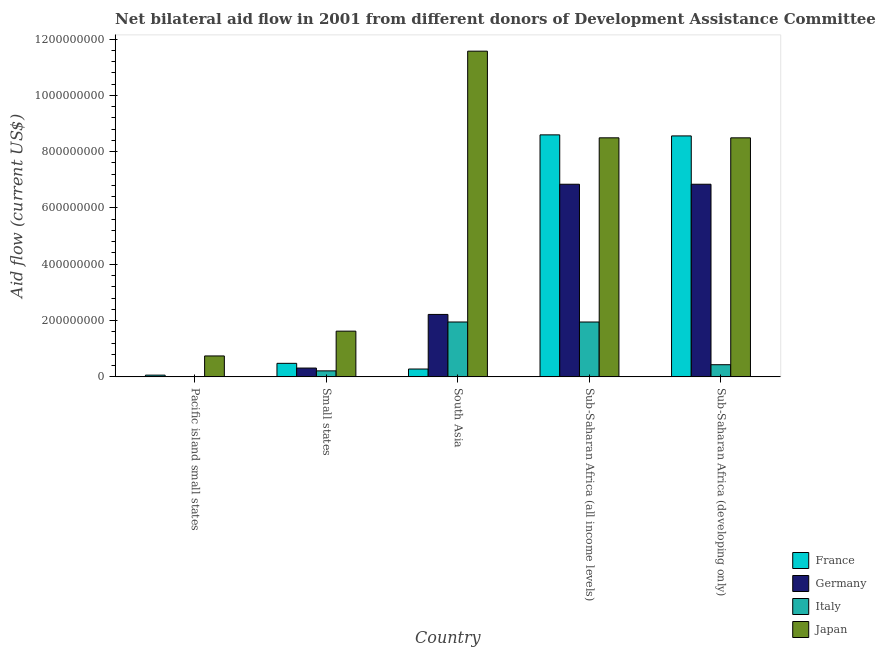How many different coloured bars are there?
Provide a succinct answer. 4. Are the number of bars per tick equal to the number of legend labels?
Ensure brevity in your answer.  No. How many bars are there on the 1st tick from the left?
Provide a short and direct response. 2. How many bars are there on the 1st tick from the right?
Ensure brevity in your answer.  4. What is the amount of aid given by japan in Sub-Saharan Africa (developing only)?
Provide a short and direct response. 8.49e+08. Across all countries, what is the maximum amount of aid given by italy?
Offer a terse response. 1.95e+08. In which country was the amount of aid given by germany maximum?
Offer a very short reply. Sub-Saharan Africa (all income levels). What is the total amount of aid given by japan in the graph?
Ensure brevity in your answer.  3.09e+09. What is the difference between the amount of aid given by japan in South Asia and that in Sub-Saharan Africa (all income levels)?
Offer a very short reply. 3.08e+08. What is the difference between the amount of aid given by france in Pacific island small states and the amount of aid given by italy in Sub-Saharan Africa (developing only)?
Make the answer very short. -3.71e+07. What is the average amount of aid given by japan per country?
Your response must be concise. 6.18e+08. What is the difference between the amount of aid given by germany and amount of aid given by italy in Small states?
Keep it short and to the point. 9.96e+06. In how many countries, is the amount of aid given by france greater than 1000000000 US$?
Your response must be concise. 0. What is the ratio of the amount of aid given by france in Small states to that in Sub-Saharan Africa (developing only)?
Your response must be concise. 0.06. Is the amount of aid given by italy in Small states less than that in Sub-Saharan Africa (all income levels)?
Your answer should be very brief. Yes. Is the difference between the amount of aid given by germany in South Asia and Sub-Saharan Africa (developing only) greater than the difference between the amount of aid given by france in South Asia and Sub-Saharan Africa (developing only)?
Offer a very short reply. Yes. What is the difference between the highest and the second highest amount of aid given by france?
Ensure brevity in your answer.  3.73e+06. What is the difference between the highest and the lowest amount of aid given by france?
Give a very brief answer. 8.53e+08. Is it the case that in every country, the sum of the amount of aid given by france and amount of aid given by germany is greater than the amount of aid given by italy?
Ensure brevity in your answer.  Yes. How many bars are there?
Offer a terse response. 18. How many countries are there in the graph?
Give a very brief answer. 5. Does the graph contain grids?
Give a very brief answer. No. Where does the legend appear in the graph?
Ensure brevity in your answer.  Bottom right. What is the title of the graph?
Ensure brevity in your answer.  Net bilateral aid flow in 2001 from different donors of Development Assistance Committee. What is the label or title of the Y-axis?
Offer a very short reply. Aid flow (current US$). What is the Aid flow (current US$) of France in Pacific island small states?
Make the answer very short. 6.15e+06. What is the Aid flow (current US$) in Germany in Pacific island small states?
Offer a terse response. 0. What is the Aid flow (current US$) in Italy in Pacific island small states?
Your response must be concise. 0. What is the Aid flow (current US$) in Japan in Pacific island small states?
Provide a short and direct response. 7.44e+07. What is the Aid flow (current US$) in France in Small states?
Your answer should be compact. 4.81e+07. What is the Aid flow (current US$) in Germany in Small states?
Your answer should be compact. 3.13e+07. What is the Aid flow (current US$) in Italy in Small states?
Your response must be concise. 2.14e+07. What is the Aid flow (current US$) in Japan in Small states?
Ensure brevity in your answer.  1.62e+08. What is the Aid flow (current US$) in France in South Asia?
Ensure brevity in your answer.  2.79e+07. What is the Aid flow (current US$) in Germany in South Asia?
Make the answer very short. 2.22e+08. What is the Aid flow (current US$) in Italy in South Asia?
Give a very brief answer. 1.95e+08. What is the Aid flow (current US$) in Japan in South Asia?
Keep it short and to the point. 1.16e+09. What is the Aid flow (current US$) of France in Sub-Saharan Africa (all income levels)?
Ensure brevity in your answer.  8.60e+08. What is the Aid flow (current US$) of Germany in Sub-Saharan Africa (all income levels)?
Provide a short and direct response. 6.84e+08. What is the Aid flow (current US$) of Italy in Sub-Saharan Africa (all income levels)?
Keep it short and to the point. 1.95e+08. What is the Aid flow (current US$) in Japan in Sub-Saharan Africa (all income levels)?
Offer a very short reply. 8.49e+08. What is the Aid flow (current US$) in France in Sub-Saharan Africa (developing only)?
Ensure brevity in your answer.  8.56e+08. What is the Aid flow (current US$) in Germany in Sub-Saharan Africa (developing only)?
Provide a succinct answer. 6.84e+08. What is the Aid flow (current US$) in Italy in Sub-Saharan Africa (developing only)?
Your response must be concise. 4.32e+07. What is the Aid flow (current US$) of Japan in Sub-Saharan Africa (developing only)?
Provide a succinct answer. 8.49e+08. Across all countries, what is the maximum Aid flow (current US$) of France?
Ensure brevity in your answer.  8.60e+08. Across all countries, what is the maximum Aid flow (current US$) of Germany?
Give a very brief answer. 6.84e+08. Across all countries, what is the maximum Aid flow (current US$) of Italy?
Ensure brevity in your answer.  1.95e+08. Across all countries, what is the maximum Aid flow (current US$) of Japan?
Keep it short and to the point. 1.16e+09. Across all countries, what is the minimum Aid flow (current US$) in France?
Provide a short and direct response. 6.15e+06. Across all countries, what is the minimum Aid flow (current US$) in Japan?
Offer a very short reply. 7.44e+07. What is the total Aid flow (current US$) of France in the graph?
Provide a short and direct response. 1.80e+09. What is the total Aid flow (current US$) in Germany in the graph?
Offer a terse response. 1.62e+09. What is the total Aid flow (current US$) of Italy in the graph?
Your response must be concise. 4.54e+08. What is the total Aid flow (current US$) in Japan in the graph?
Ensure brevity in your answer.  3.09e+09. What is the difference between the Aid flow (current US$) in France in Pacific island small states and that in Small states?
Make the answer very short. -4.20e+07. What is the difference between the Aid flow (current US$) in Japan in Pacific island small states and that in Small states?
Make the answer very short. -8.80e+07. What is the difference between the Aid flow (current US$) in France in Pacific island small states and that in South Asia?
Provide a succinct answer. -2.17e+07. What is the difference between the Aid flow (current US$) of Japan in Pacific island small states and that in South Asia?
Your answer should be compact. -1.08e+09. What is the difference between the Aid flow (current US$) in France in Pacific island small states and that in Sub-Saharan Africa (all income levels)?
Provide a short and direct response. -8.53e+08. What is the difference between the Aid flow (current US$) in Japan in Pacific island small states and that in Sub-Saharan Africa (all income levels)?
Your answer should be compact. -7.75e+08. What is the difference between the Aid flow (current US$) in France in Pacific island small states and that in Sub-Saharan Africa (developing only)?
Your answer should be very brief. -8.50e+08. What is the difference between the Aid flow (current US$) of Japan in Pacific island small states and that in Sub-Saharan Africa (developing only)?
Offer a terse response. -7.75e+08. What is the difference between the Aid flow (current US$) in France in Small states and that in South Asia?
Provide a short and direct response. 2.02e+07. What is the difference between the Aid flow (current US$) in Germany in Small states and that in South Asia?
Offer a very short reply. -1.90e+08. What is the difference between the Aid flow (current US$) in Italy in Small states and that in South Asia?
Ensure brevity in your answer.  -1.74e+08. What is the difference between the Aid flow (current US$) in Japan in Small states and that in South Asia?
Make the answer very short. -9.94e+08. What is the difference between the Aid flow (current US$) in France in Small states and that in Sub-Saharan Africa (all income levels)?
Provide a short and direct response. -8.11e+08. What is the difference between the Aid flow (current US$) in Germany in Small states and that in Sub-Saharan Africa (all income levels)?
Keep it short and to the point. -6.53e+08. What is the difference between the Aid flow (current US$) of Italy in Small states and that in Sub-Saharan Africa (all income levels)?
Keep it short and to the point. -1.74e+08. What is the difference between the Aid flow (current US$) in Japan in Small states and that in Sub-Saharan Africa (all income levels)?
Ensure brevity in your answer.  -6.87e+08. What is the difference between the Aid flow (current US$) in France in Small states and that in Sub-Saharan Africa (developing only)?
Offer a terse response. -8.08e+08. What is the difference between the Aid flow (current US$) of Germany in Small states and that in Sub-Saharan Africa (developing only)?
Provide a succinct answer. -6.53e+08. What is the difference between the Aid flow (current US$) of Italy in Small states and that in Sub-Saharan Africa (developing only)?
Keep it short and to the point. -2.19e+07. What is the difference between the Aid flow (current US$) in Japan in Small states and that in Sub-Saharan Africa (developing only)?
Provide a succinct answer. -6.87e+08. What is the difference between the Aid flow (current US$) in France in South Asia and that in Sub-Saharan Africa (all income levels)?
Your answer should be very brief. -8.32e+08. What is the difference between the Aid flow (current US$) of Germany in South Asia and that in Sub-Saharan Africa (all income levels)?
Make the answer very short. -4.62e+08. What is the difference between the Aid flow (current US$) in Italy in South Asia and that in Sub-Saharan Africa (all income levels)?
Provide a short and direct response. 2.00e+04. What is the difference between the Aid flow (current US$) of Japan in South Asia and that in Sub-Saharan Africa (all income levels)?
Provide a short and direct response. 3.08e+08. What is the difference between the Aid flow (current US$) in France in South Asia and that in Sub-Saharan Africa (developing only)?
Your response must be concise. -8.28e+08. What is the difference between the Aid flow (current US$) in Germany in South Asia and that in Sub-Saharan Africa (developing only)?
Keep it short and to the point. -4.62e+08. What is the difference between the Aid flow (current US$) in Italy in South Asia and that in Sub-Saharan Africa (developing only)?
Ensure brevity in your answer.  1.52e+08. What is the difference between the Aid flow (current US$) of Japan in South Asia and that in Sub-Saharan Africa (developing only)?
Provide a short and direct response. 3.08e+08. What is the difference between the Aid flow (current US$) in France in Sub-Saharan Africa (all income levels) and that in Sub-Saharan Africa (developing only)?
Make the answer very short. 3.73e+06. What is the difference between the Aid flow (current US$) in Germany in Sub-Saharan Africa (all income levels) and that in Sub-Saharan Africa (developing only)?
Give a very brief answer. 0. What is the difference between the Aid flow (current US$) in Italy in Sub-Saharan Africa (all income levels) and that in Sub-Saharan Africa (developing only)?
Provide a succinct answer. 1.52e+08. What is the difference between the Aid flow (current US$) of France in Pacific island small states and the Aid flow (current US$) of Germany in Small states?
Keep it short and to the point. -2.52e+07. What is the difference between the Aid flow (current US$) of France in Pacific island small states and the Aid flow (current US$) of Italy in Small states?
Give a very brief answer. -1.52e+07. What is the difference between the Aid flow (current US$) in France in Pacific island small states and the Aid flow (current US$) in Japan in Small states?
Your answer should be very brief. -1.56e+08. What is the difference between the Aid flow (current US$) of France in Pacific island small states and the Aid flow (current US$) of Germany in South Asia?
Your response must be concise. -2.16e+08. What is the difference between the Aid flow (current US$) of France in Pacific island small states and the Aid flow (current US$) of Italy in South Asia?
Give a very brief answer. -1.89e+08. What is the difference between the Aid flow (current US$) of France in Pacific island small states and the Aid flow (current US$) of Japan in South Asia?
Offer a terse response. -1.15e+09. What is the difference between the Aid flow (current US$) in France in Pacific island small states and the Aid flow (current US$) in Germany in Sub-Saharan Africa (all income levels)?
Your answer should be compact. -6.78e+08. What is the difference between the Aid flow (current US$) in France in Pacific island small states and the Aid flow (current US$) in Italy in Sub-Saharan Africa (all income levels)?
Provide a succinct answer. -1.89e+08. What is the difference between the Aid flow (current US$) in France in Pacific island small states and the Aid flow (current US$) in Japan in Sub-Saharan Africa (all income levels)?
Your response must be concise. -8.43e+08. What is the difference between the Aid flow (current US$) of France in Pacific island small states and the Aid flow (current US$) of Germany in Sub-Saharan Africa (developing only)?
Your answer should be compact. -6.78e+08. What is the difference between the Aid flow (current US$) in France in Pacific island small states and the Aid flow (current US$) in Italy in Sub-Saharan Africa (developing only)?
Make the answer very short. -3.71e+07. What is the difference between the Aid flow (current US$) of France in Pacific island small states and the Aid flow (current US$) of Japan in Sub-Saharan Africa (developing only)?
Your answer should be very brief. -8.43e+08. What is the difference between the Aid flow (current US$) in France in Small states and the Aid flow (current US$) in Germany in South Asia?
Provide a succinct answer. -1.74e+08. What is the difference between the Aid flow (current US$) of France in Small states and the Aid flow (current US$) of Italy in South Asia?
Provide a succinct answer. -1.47e+08. What is the difference between the Aid flow (current US$) of France in Small states and the Aid flow (current US$) of Japan in South Asia?
Your response must be concise. -1.11e+09. What is the difference between the Aid flow (current US$) in Germany in Small states and the Aid flow (current US$) in Italy in South Asia?
Provide a succinct answer. -1.64e+08. What is the difference between the Aid flow (current US$) in Germany in Small states and the Aid flow (current US$) in Japan in South Asia?
Provide a short and direct response. -1.13e+09. What is the difference between the Aid flow (current US$) of Italy in Small states and the Aid flow (current US$) of Japan in South Asia?
Your answer should be compact. -1.14e+09. What is the difference between the Aid flow (current US$) in France in Small states and the Aid flow (current US$) in Germany in Sub-Saharan Africa (all income levels)?
Your answer should be very brief. -6.36e+08. What is the difference between the Aid flow (current US$) in France in Small states and the Aid flow (current US$) in Italy in Sub-Saharan Africa (all income levels)?
Your answer should be very brief. -1.47e+08. What is the difference between the Aid flow (current US$) in France in Small states and the Aid flow (current US$) in Japan in Sub-Saharan Africa (all income levels)?
Your response must be concise. -8.01e+08. What is the difference between the Aid flow (current US$) of Germany in Small states and the Aid flow (current US$) of Italy in Sub-Saharan Africa (all income levels)?
Offer a terse response. -1.64e+08. What is the difference between the Aid flow (current US$) in Germany in Small states and the Aid flow (current US$) in Japan in Sub-Saharan Africa (all income levels)?
Your answer should be very brief. -8.18e+08. What is the difference between the Aid flow (current US$) in Italy in Small states and the Aid flow (current US$) in Japan in Sub-Saharan Africa (all income levels)?
Offer a very short reply. -8.28e+08. What is the difference between the Aid flow (current US$) of France in Small states and the Aid flow (current US$) of Germany in Sub-Saharan Africa (developing only)?
Your response must be concise. -6.36e+08. What is the difference between the Aid flow (current US$) in France in Small states and the Aid flow (current US$) in Italy in Sub-Saharan Africa (developing only)?
Keep it short and to the point. 4.89e+06. What is the difference between the Aid flow (current US$) in France in Small states and the Aid flow (current US$) in Japan in Sub-Saharan Africa (developing only)?
Provide a short and direct response. -8.01e+08. What is the difference between the Aid flow (current US$) in Germany in Small states and the Aid flow (current US$) in Italy in Sub-Saharan Africa (developing only)?
Your answer should be very brief. -1.19e+07. What is the difference between the Aid flow (current US$) in Germany in Small states and the Aid flow (current US$) in Japan in Sub-Saharan Africa (developing only)?
Your response must be concise. -8.18e+08. What is the difference between the Aid flow (current US$) of Italy in Small states and the Aid flow (current US$) of Japan in Sub-Saharan Africa (developing only)?
Give a very brief answer. -8.28e+08. What is the difference between the Aid flow (current US$) of France in South Asia and the Aid flow (current US$) of Germany in Sub-Saharan Africa (all income levels)?
Your response must be concise. -6.56e+08. What is the difference between the Aid flow (current US$) in France in South Asia and the Aid flow (current US$) in Italy in Sub-Saharan Africa (all income levels)?
Ensure brevity in your answer.  -1.67e+08. What is the difference between the Aid flow (current US$) in France in South Asia and the Aid flow (current US$) in Japan in Sub-Saharan Africa (all income levels)?
Offer a very short reply. -8.21e+08. What is the difference between the Aid flow (current US$) in Germany in South Asia and the Aid flow (current US$) in Italy in Sub-Saharan Africa (all income levels)?
Your answer should be compact. 2.69e+07. What is the difference between the Aid flow (current US$) of Germany in South Asia and the Aid flow (current US$) of Japan in Sub-Saharan Africa (all income levels)?
Keep it short and to the point. -6.27e+08. What is the difference between the Aid flow (current US$) in Italy in South Asia and the Aid flow (current US$) in Japan in Sub-Saharan Africa (all income levels)?
Make the answer very short. -6.54e+08. What is the difference between the Aid flow (current US$) in France in South Asia and the Aid flow (current US$) in Germany in Sub-Saharan Africa (developing only)?
Your answer should be compact. -6.56e+08. What is the difference between the Aid flow (current US$) in France in South Asia and the Aid flow (current US$) in Italy in Sub-Saharan Africa (developing only)?
Provide a short and direct response. -1.54e+07. What is the difference between the Aid flow (current US$) of France in South Asia and the Aid flow (current US$) of Japan in Sub-Saharan Africa (developing only)?
Provide a short and direct response. -8.21e+08. What is the difference between the Aid flow (current US$) in Germany in South Asia and the Aid flow (current US$) in Italy in Sub-Saharan Africa (developing only)?
Your response must be concise. 1.79e+08. What is the difference between the Aid flow (current US$) in Germany in South Asia and the Aid flow (current US$) in Japan in Sub-Saharan Africa (developing only)?
Your answer should be very brief. -6.27e+08. What is the difference between the Aid flow (current US$) of Italy in South Asia and the Aid flow (current US$) of Japan in Sub-Saharan Africa (developing only)?
Offer a terse response. -6.54e+08. What is the difference between the Aid flow (current US$) of France in Sub-Saharan Africa (all income levels) and the Aid flow (current US$) of Germany in Sub-Saharan Africa (developing only)?
Offer a terse response. 1.75e+08. What is the difference between the Aid flow (current US$) of France in Sub-Saharan Africa (all income levels) and the Aid flow (current US$) of Italy in Sub-Saharan Africa (developing only)?
Provide a succinct answer. 8.16e+08. What is the difference between the Aid flow (current US$) in France in Sub-Saharan Africa (all income levels) and the Aid flow (current US$) in Japan in Sub-Saharan Africa (developing only)?
Your answer should be very brief. 1.05e+07. What is the difference between the Aid flow (current US$) of Germany in Sub-Saharan Africa (all income levels) and the Aid flow (current US$) of Italy in Sub-Saharan Africa (developing only)?
Your answer should be very brief. 6.41e+08. What is the difference between the Aid flow (current US$) in Germany in Sub-Saharan Africa (all income levels) and the Aid flow (current US$) in Japan in Sub-Saharan Africa (developing only)?
Offer a terse response. -1.65e+08. What is the difference between the Aid flow (current US$) of Italy in Sub-Saharan Africa (all income levels) and the Aid flow (current US$) of Japan in Sub-Saharan Africa (developing only)?
Your answer should be compact. -6.54e+08. What is the average Aid flow (current US$) of France per country?
Your answer should be very brief. 3.59e+08. What is the average Aid flow (current US$) in Germany per country?
Your response must be concise. 3.24e+08. What is the average Aid flow (current US$) of Italy per country?
Your response must be concise. 9.09e+07. What is the average Aid flow (current US$) of Japan per country?
Offer a terse response. 6.18e+08. What is the difference between the Aid flow (current US$) in France and Aid flow (current US$) in Japan in Pacific island small states?
Your answer should be compact. -6.82e+07. What is the difference between the Aid flow (current US$) of France and Aid flow (current US$) of Germany in Small states?
Ensure brevity in your answer.  1.68e+07. What is the difference between the Aid flow (current US$) of France and Aid flow (current US$) of Italy in Small states?
Provide a succinct answer. 2.68e+07. What is the difference between the Aid flow (current US$) of France and Aid flow (current US$) of Japan in Small states?
Ensure brevity in your answer.  -1.14e+08. What is the difference between the Aid flow (current US$) of Germany and Aid flow (current US$) of Italy in Small states?
Offer a very short reply. 9.96e+06. What is the difference between the Aid flow (current US$) of Germany and Aid flow (current US$) of Japan in Small states?
Make the answer very short. -1.31e+08. What is the difference between the Aid flow (current US$) in Italy and Aid flow (current US$) in Japan in Small states?
Your response must be concise. -1.41e+08. What is the difference between the Aid flow (current US$) of France and Aid flow (current US$) of Germany in South Asia?
Ensure brevity in your answer.  -1.94e+08. What is the difference between the Aid flow (current US$) of France and Aid flow (current US$) of Italy in South Asia?
Ensure brevity in your answer.  -1.67e+08. What is the difference between the Aid flow (current US$) of France and Aid flow (current US$) of Japan in South Asia?
Offer a terse response. -1.13e+09. What is the difference between the Aid flow (current US$) of Germany and Aid flow (current US$) of Italy in South Asia?
Keep it short and to the point. 2.69e+07. What is the difference between the Aid flow (current US$) in Germany and Aid flow (current US$) in Japan in South Asia?
Your answer should be compact. -9.35e+08. What is the difference between the Aid flow (current US$) of Italy and Aid flow (current US$) of Japan in South Asia?
Offer a terse response. -9.62e+08. What is the difference between the Aid flow (current US$) of France and Aid flow (current US$) of Germany in Sub-Saharan Africa (all income levels)?
Your answer should be very brief. 1.75e+08. What is the difference between the Aid flow (current US$) in France and Aid flow (current US$) in Italy in Sub-Saharan Africa (all income levels)?
Your answer should be compact. 6.65e+08. What is the difference between the Aid flow (current US$) of France and Aid flow (current US$) of Japan in Sub-Saharan Africa (all income levels)?
Keep it short and to the point. 1.05e+07. What is the difference between the Aid flow (current US$) in Germany and Aid flow (current US$) in Italy in Sub-Saharan Africa (all income levels)?
Make the answer very short. 4.89e+08. What is the difference between the Aid flow (current US$) in Germany and Aid flow (current US$) in Japan in Sub-Saharan Africa (all income levels)?
Provide a succinct answer. -1.65e+08. What is the difference between the Aid flow (current US$) of Italy and Aid flow (current US$) of Japan in Sub-Saharan Africa (all income levels)?
Offer a very short reply. -6.54e+08. What is the difference between the Aid flow (current US$) of France and Aid flow (current US$) of Germany in Sub-Saharan Africa (developing only)?
Make the answer very short. 1.72e+08. What is the difference between the Aid flow (current US$) in France and Aid flow (current US$) in Italy in Sub-Saharan Africa (developing only)?
Keep it short and to the point. 8.13e+08. What is the difference between the Aid flow (current US$) of France and Aid flow (current US$) of Japan in Sub-Saharan Africa (developing only)?
Keep it short and to the point. 6.80e+06. What is the difference between the Aid flow (current US$) of Germany and Aid flow (current US$) of Italy in Sub-Saharan Africa (developing only)?
Your response must be concise. 6.41e+08. What is the difference between the Aid flow (current US$) of Germany and Aid flow (current US$) of Japan in Sub-Saharan Africa (developing only)?
Provide a short and direct response. -1.65e+08. What is the difference between the Aid flow (current US$) of Italy and Aid flow (current US$) of Japan in Sub-Saharan Africa (developing only)?
Ensure brevity in your answer.  -8.06e+08. What is the ratio of the Aid flow (current US$) in France in Pacific island small states to that in Small states?
Provide a short and direct response. 0.13. What is the ratio of the Aid flow (current US$) in Japan in Pacific island small states to that in Small states?
Offer a terse response. 0.46. What is the ratio of the Aid flow (current US$) in France in Pacific island small states to that in South Asia?
Make the answer very short. 0.22. What is the ratio of the Aid flow (current US$) in Japan in Pacific island small states to that in South Asia?
Your answer should be very brief. 0.06. What is the ratio of the Aid flow (current US$) of France in Pacific island small states to that in Sub-Saharan Africa (all income levels)?
Your answer should be very brief. 0.01. What is the ratio of the Aid flow (current US$) in Japan in Pacific island small states to that in Sub-Saharan Africa (all income levels)?
Provide a succinct answer. 0.09. What is the ratio of the Aid flow (current US$) in France in Pacific island small states to that in Sub-Saharan Africa (developing only)?
Make the answer very short. 0.01. What is the ratio of the Aid flow (current US$) in Japan in Pacific island small states to that in Sub-Saharan Africa (developing only)?
Offer a terse response. 0.09. What is the ratio of the Aid flow (current US$) of France in Small states to that in South Asia?
Give a very brief answer. 1.73. What is the ratio of the Aid flow (current US$) of Germany in Small states to that in South Asia?
Provide a succinct answer. 0.14. What is the ratio of the Aid flow (current US$) in Italy in Small states to that in South Asia?
Your response must be concise. 0.11. What is the ratio of the Aid flow (current US$) of Japan in Small states to that in South Asia?
Offer a terse response. 0.14. What is the ratio of the Aid flow (current US$) of France in Small states to that in Sub-Saharan Africa (all income levels)?
Your response must be concise. 0.06. What is the ratio of the Aid flow (current US$) in Germany in Small states to that in Sub-Saharan Africa (all income levels)?
Ensure brevity in your answer.  0.05. What is the ratio of the Aid flow (current US$) in Italy in Small states to that in Sub-Saharan Africa (all income levels)?
Ensure brevity in your answer.  0.11. What is the ratio of the Aid flow (current US$) in Japan in Small states to that in Sub-Saharan Africa (all income levels)?
Your response must be concise. 0.19. What is the ratio of the Aid flow (current US$) of France in Small states to that in Sub-Saharan Africa (developing only)?
Ensure brevity in your answer.  0.06. What is the ratio of the Aid flow (current US$) in Germany in Small states to that in Sub-Saharan Africa (developing only)?
Give a very brief answer. 0.05. What is the ratio of the Aid flow (current US$) in Italy in Small states to that in Sub-Saharan Africa (developing only)?
Offer a very short reply. 0.49. What is the ratio of the Aid flow (current US$) of Japan in Small states to that in Sub-Saharan Africa (developing only)?
Offer a terse response. 0.19. What is the ratio of the Aid flow (current US$) in France in South Asia to that in Sub-Saharan Africa (all income levels)?
Your answer should be compact. 0.03. What is the ratio of the Aid flow (current US$) of Germany in South Asia to that in Sub-Saharan Africa (all income levels)?
Offer a terse response. 0.32. What is the ratio of the Aid flow (current US$) in Italy in South Asia to that in Sub-Saharan Africa (all income levels)?
Your answer should be compact. 1. What is the ratio of the Aid flow (current US$) of Japan in South Asia to that in Sub-Saharan Africa (all income levels)?
Provide a succinct answer. 1.36. What is the ratio of the Aid flow (current US$) in France in South Asia to that in Sub-Saharan Africa (developing only)?
Your response must be concise. 0.03. What is the ratio of the Aid flow (current US$) of Germany in South Asia to that in Sub-Saharan Africa (developing only)?
Offer a very short reply. 0.32. What is the ratio of the Aid flow (current US$) in Italy in South Asia to that in Sub-Saharan Africa (developing only)?
Provide a succinct answer. 4.51. What is the ratio of the Aid flow (current US$) in Japan in South Asia to that in Sub-Saharan Africa (developing only)?
Ensure brevity in your answer.  1.36. What is the ratio of the Aid flow (current US$) in Italy in Sub-Saharan Africa (all income levels) to that in Sub-Saharan Africa (developing only)?
Offer a terse response. 4.51. What is the ratio of the Aid flow (current US$) in Japan in Sub-Saharan Africa (all income levels) to that in Sub-Saharan Africa (developing only)?
Your answer should be very brief. 1. What is the difference between the highest and the second highest Aid flow (current US$) in France?
Ensure brevity in your answer.  3.73e+06. What is the difference between the highest and the second highest Aid flow (current US$) in Italy?
Offer a terse response. 2.00e+04. What is the difference between the highest and the second highest Aid flow (current US$) of Japan?
Your answer should be compact. 3.08e+08. What is the difference between the highest and the lowest Aid flow (current US$) of France?
Provide a succinct answer. 8.53e+08. What is the difference between the highest and the lowest Aid flow (current US$) of Germany?
Provide a succinct answer. 6.84e+08. What is the difference between the highest and the lowest Aid flow (current US$) of Italy?
Offer a terse response. 1.95e+08. What is the difference between the highest and the lowest Aid flow (current US$) of Japan?
Offer a terse response. 1.08e+09. 